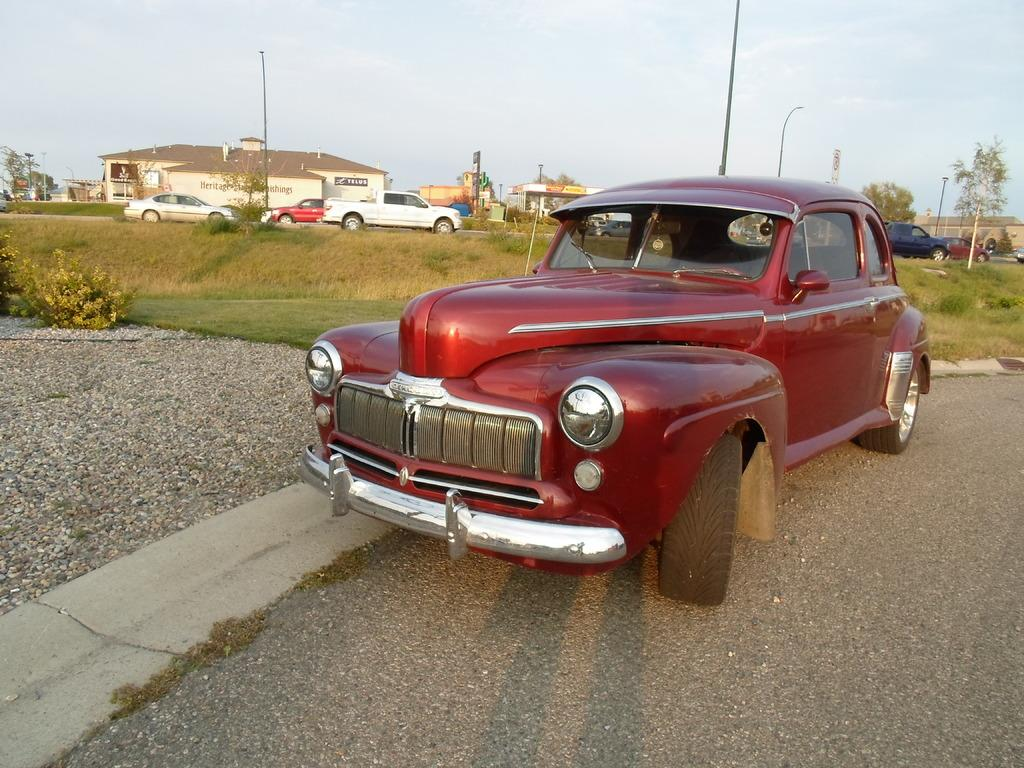What color is the car in the image? The car in the image is maroon. What can be seen in the background of the image? In the background of the image, there are plants, grass, poles, trees, buildings, other cars, and the sky. Can you describe the shadow in the image? There is a shadow in the image, but its specific details are not clear from the provided facts. What color is the chalk used to draw on the car in the image? There is no chalk or drawing on the car in the image; it is simply a maroon color car. How does the person in the image ask for help? There is no person present in the image, so it is not possible to determine how they might ask for help. 